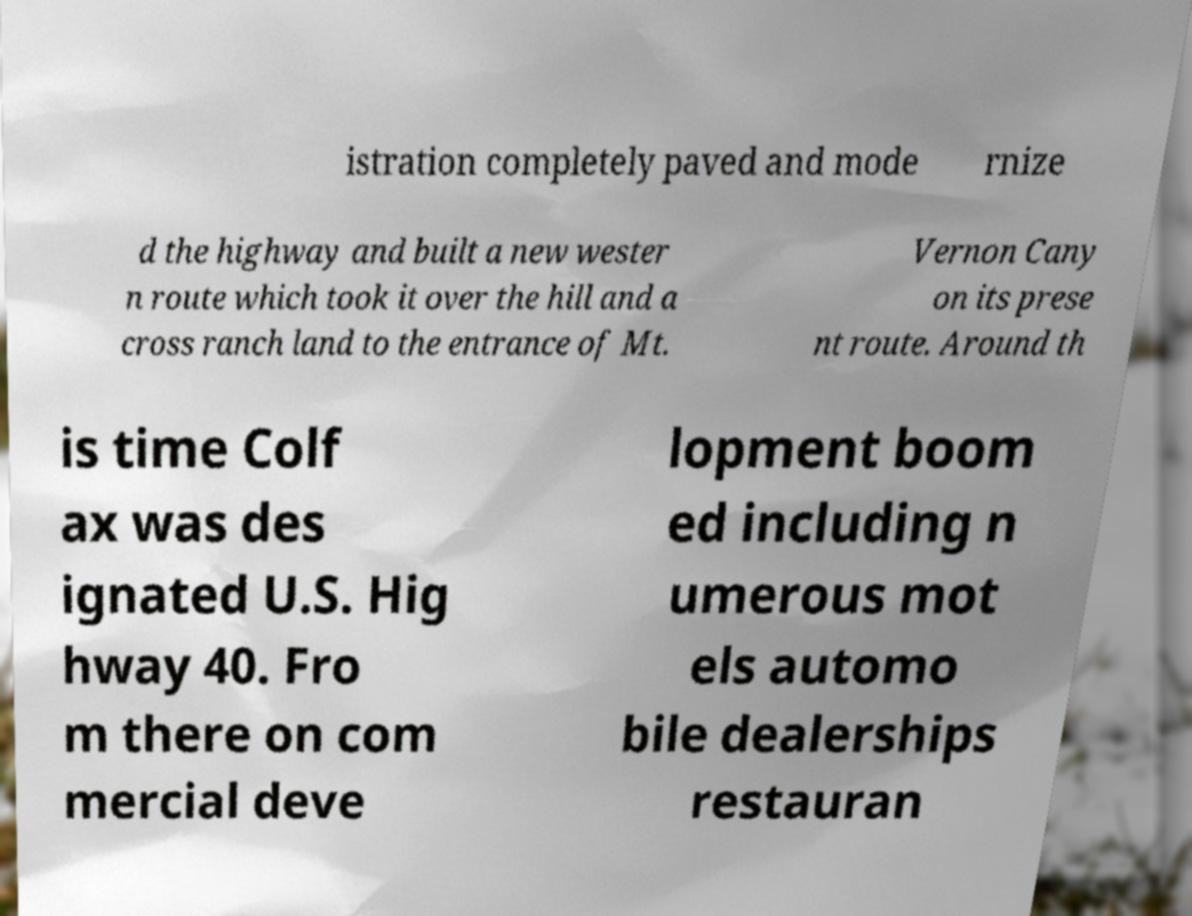What messages or text are displayed in this image? I need them in a readable, typed format. istration completely paved and mode rnize d the highway and built a new wester n route which took it over the hill and a cross ranch land to the entrance of Mt. Vernon Cany on its prese nt route. Around th is time Colf ax was des ignated U.S. Hig hway 40. Fro m there on com mercial deve lopment boom ed including n umerous mot els automo bile dealerships restauran 